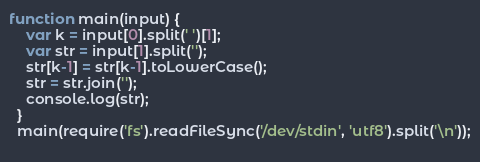Convert code to text. <code><loc_0><loc_0><loc_500><loc_500><_JavaScript_>function main(input) {
    var k = input[0].split(' ')[1];
    var str = input[1].split('');
    str[k-1] = str[k-1].toLowerCase();
    str = str.join('');
    console.log(str);
  }
  main(require('fs').readFileSync('/dev/stdin', 'utf8').split('\n'));
  </code> 